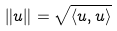Convert formula to latex. <formula><loc_0><loc_0><loc_500><loc_500>\| u \| = \sqrt { \langle u , u \rangle }</formula> 